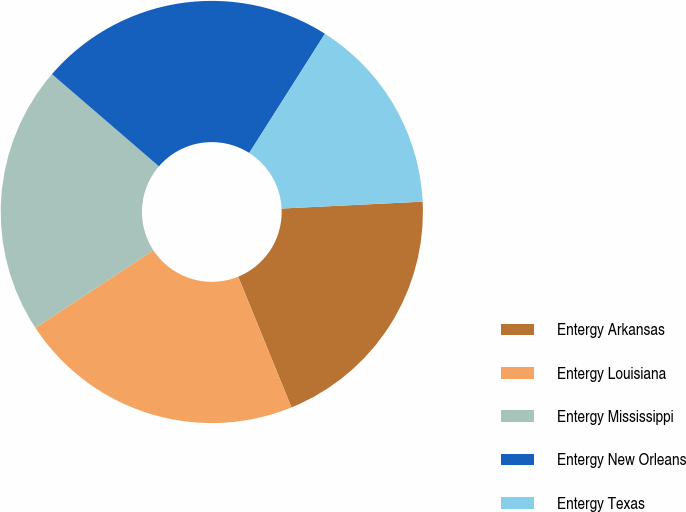Convert chart. <chart><loc_0><loc_0><loc_500><loc_500><pie_chart><fcel>Entergy Arkansas<fcel>Entergy Louisiana<fcel>Entergy Mississippi<fcel>Entergy New Orleans<fcel>Entergy Texas<nl><fcel>19.62%<fcel>21.91%<fcel>20.57%<fcel>22.68%<fcel>15.22%<nl></chart> 